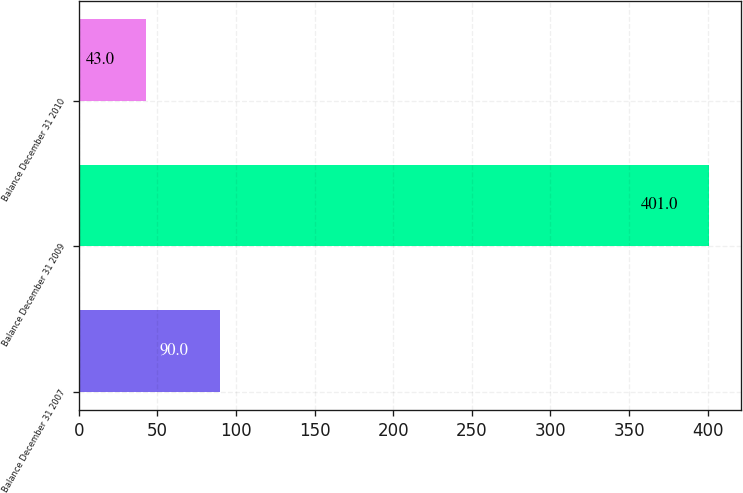Convert chart. <chart><loc_0><loc_0><loc_500><loc_500><bar_chart><fcel>Balance December 31 2007<fcel>Balance December 31 2009<fcel>Balance December 31 2010<nl><fcel>90<fcel>401<fcel>43<nl></chart> 